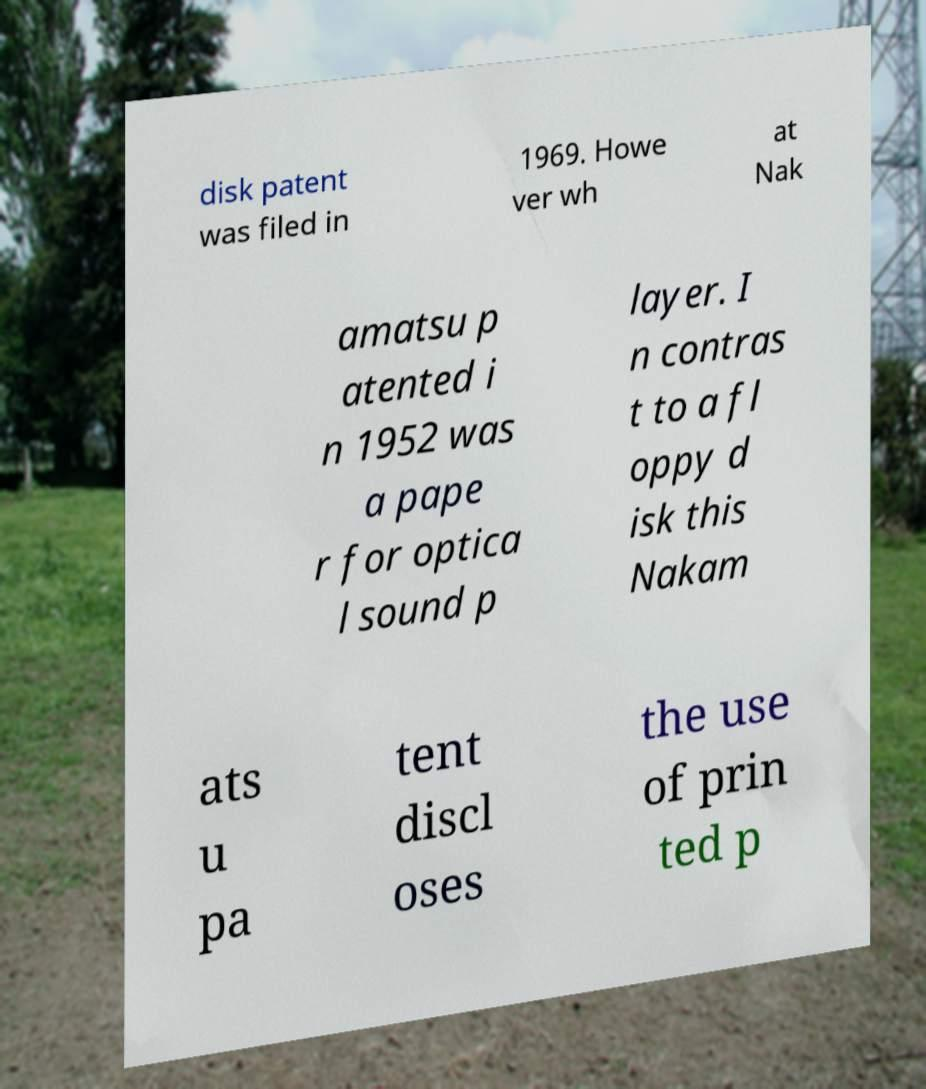What messages or text are displayed in this image? I need them in a readable, typed format. disk patent was filed in 1969. Howe ver wh at Nak amatsu p atented i n 1952 was a pape r for optica l sound p layer. I n contras t to a fl oppy d isk this Nakam ats u pa tent discl oses the use of prin ted p 